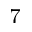<formula> <loc_0><loc_0><loc_500><loc_500>_ { 7 }</formula> 